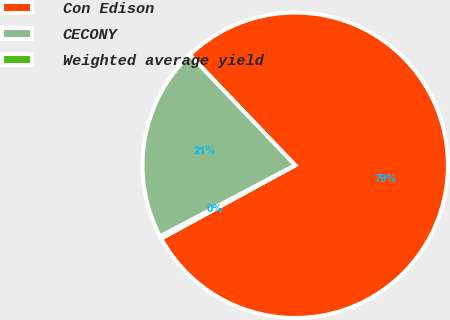Convert chart. <chart><loc_0><loc_0><loc_500><loc_500><pie_chart><fcel>Con Edison<fcel>CECONY<fcel>Weighted average yield<nl><fcel>79.17%<fcel>20.58%<fcel>0.25%<nl></chart> 